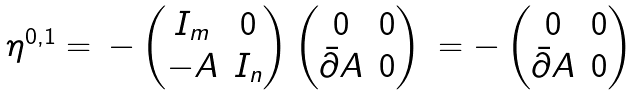Convert formula to latex. <formula><loc_0><loc_0><loc_500><loc_500>\begin{matrix} \eta ^ { 0 , 1 } = & - \begin{pmatrix} I _ { m } & 0 \\ - A & I _ { n } \end{pmatrix} \begin{pmatrix} 0 & 0 \\ \bar { \partial } A & 0 \end{pmatrix} & = - \begin{pmatrix} 0 & 0 \\ \bar { \partial } A & 0 \end{pmatrix} \end{matrix}</formula> 